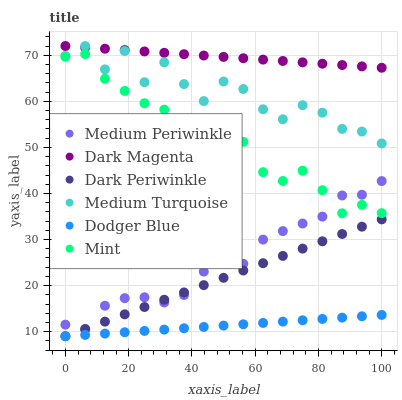Does Dodger Blue have the minimum area under the curve?
Answer yes or no. Yes. Does Dark Magenta have the maximum area under the curve?
Answer yes or no. Yes. Does Medium Periwinkle have the minimum area under the curve?
Answer yes or no. No. Does Medium Periwinkle have the maximum area under the curve?
Answer yes or no. No. Is Dodger Blue the smoothest?
Answer yes or no. Yes. Is Medium Turquoise the roughest?
Answer yes or no. Yes. Is Medium Periwinkle the smoothest?
Answer yes or no. No. Is Medium Periwinkle the roughest?
Answer yes or no. No. Does Dodger Blue have the lowest value?
Answer yes or no. Yes. Does Medium Periwinkle have the lowest value?
Answer yes or no. No. Does Dark Magenta have the highest value?
Answer yes or no. Yes. Does Medium Periwinkle have the highest value?
Answer yes or no. No. Is Dark Periwinkle less than Medium Turquoise?
Answer yes or no. Yes. Is Dark Magenta greater than Mint?
Answer yes or no. Yes. Does Dark Magenta intersect Medium Turquoise?
Answer yes or no. Yes. Is Dark Magenta less than Medium Turquoise?
Answer yes or no. No. Is Dark Magenta greater than Medium Turquoise?
Answer yes or no. No. Does Dark Periwinkle intersect Medium Turquoise?
Answer yes or no. No. 